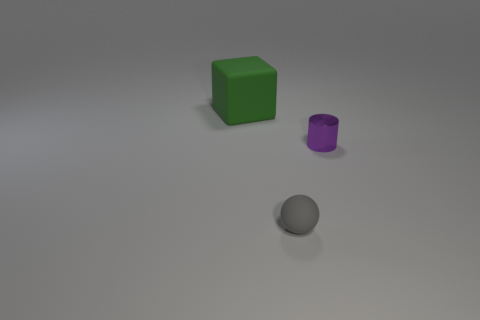Add 3 brown matte cubes. How many objects exist? 6 Subtract all blocks. How many objects are left? 2 Add 3 tiny cyan metal objects. How many tiny cyan metal objects exist? 3 Subtract 0 yellow balls. How many objects are left? 3 Subtract all tiny purple cylinders. Subtract all small matte spheres. How many objects are left? 1 Add 2 tiny gray spheres. How many tiny gray spheres are left? 3 